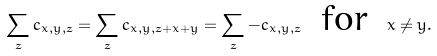Convert formula to latex. <formula><loc_0><loc_0><loc_500><loc_500>\sum _ { z } c _ { x , y , z } = \sum _ { z } c _ { x , y , z + x + y } = \sum _ { z } - c _ { x , y , z } \text {\, for \,} x \neq y .</formula> 